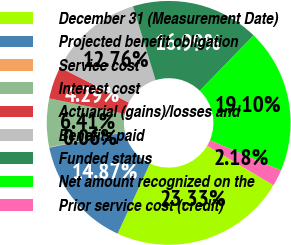Convert chart to OTSL. <chart><loc_0><loc_0><loc_500><loc_500><pie_chart><fcel>December 31 (Measurement Date)<fcel>Projected benefit obligation<fcel>Service cost<fcel>Interest cost<fcel>Actuarial (gains)/losses and<fcel>Benefits paid<fcel>Funded status<fcel>Net amount recognized on the<fcel>Prior service cost (credit)<nl><fcel>23.33%<fcel>14.87%<fcel>0.06%<fcel>6.41%<fcel>4.29%<fcel>12.76%<fcel>16.99%<fcel>19.1%<fcel>2.18%<nl></chart> 